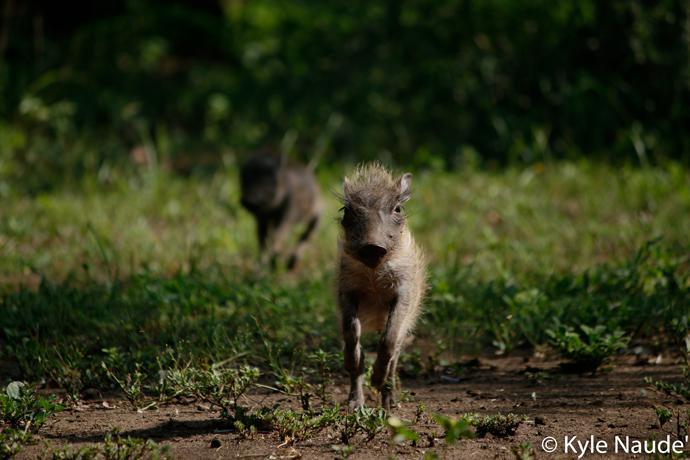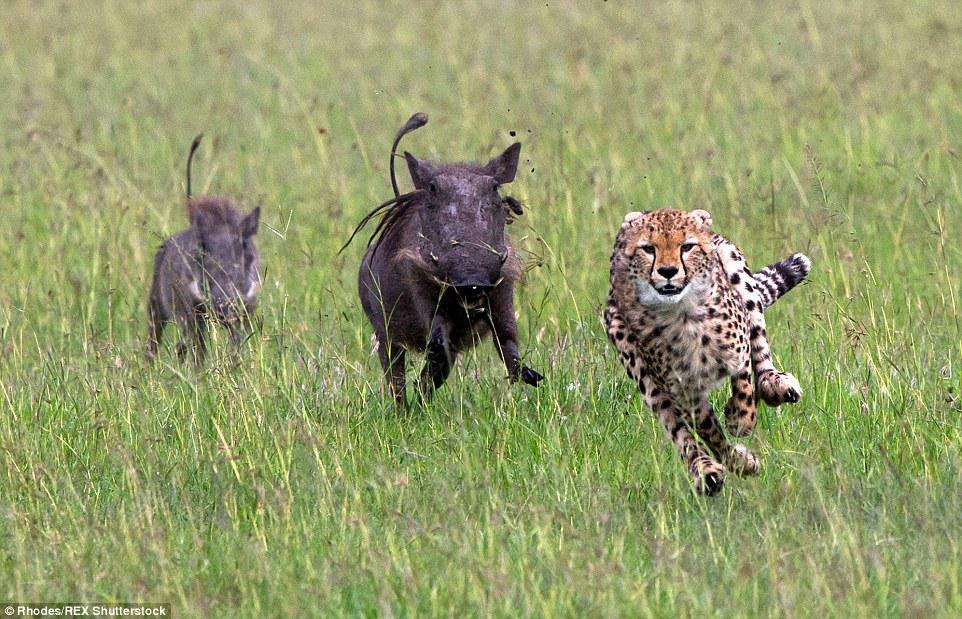The first image is the image on the left, the second image is the image on the right. Examine the images to the left and right. Is the description "There is exactly one animal in the image on the left." accurate? Answer yes or no. No. The first image is the image on the left, the second image is the image on the right. Analyze the images presented: Is the assertion "Left image shows one young hog running forward." valid? Answer yes or no. Yes. 